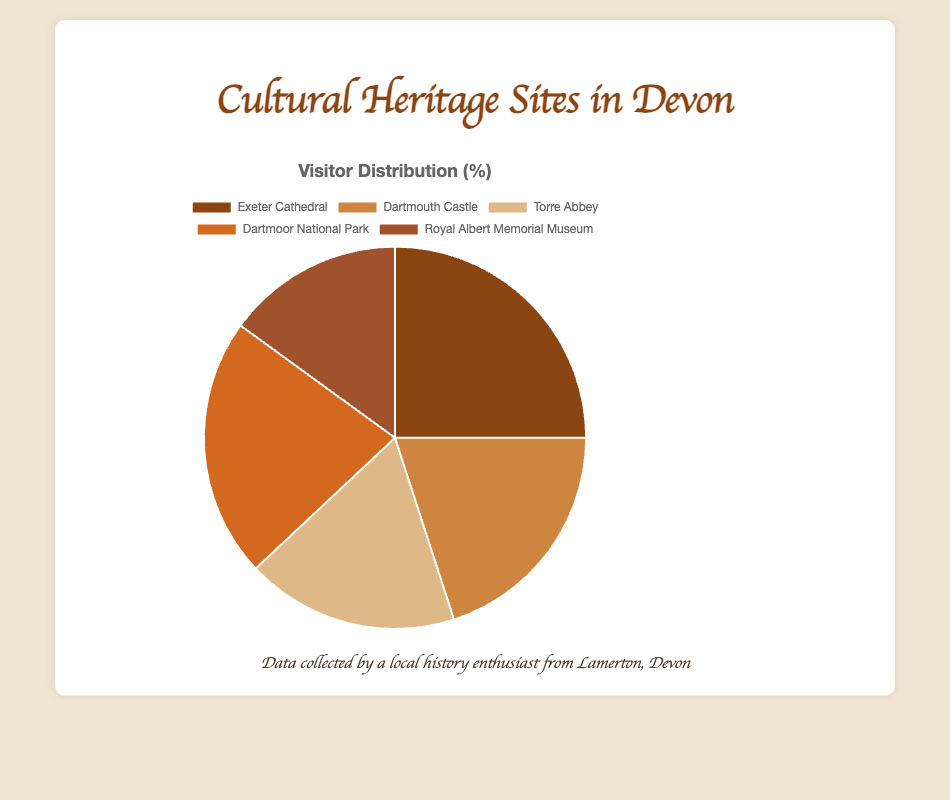Which cultural heritage site has the highest percentage of visitors? By looking at the pie chart, you can see the largest segment represents the site with the highest percentage of visitors. The largest segment is labeled "Exeter Cathedral".
Answer: Exeter Cathedral What is the combined percentage of visitors for Dartmouth Castle and Torre Abbey? Add the percentages of Dartmouth Castle (20%) and Torre Abbey (18%). This sum is 20% + 18% = 38%.
Answer: 38% Which site has fewer visitors, Royal Albert Memorial Museum or Dartmoor National Park? Compare the pie chart segments, the Royal Albert Memorial Museum segment is smaller than the Dartmoor National Park segment.
Answer: Royal Albert Memorial Museum How many percentage points more visitors does Exeter Cathedral have compared to Royal Albert Memorial Museum? Subtract the percentage of Royal Albert Memorial Museum (15%) from the percentage of Exeter Cathedral (25%). So, 25% - 15% = 10%.
Answer: 10 Which two sites together have the highest combined percentage of visitors? Find the two largest individual percentages and add them together. Exeter Cathedral (25%) and Dartmoor National Park (22%), their combined percentage is 25% + 22% = 47%.
Answer: Exeter Cathedral and Dartmoor National Park What is the difference in visitors between Torre Abbey and Dartmoor National Park? Subtract the percentage of Torre Abbey (18%) from Dartmoor National Park (22%). So, 22% - 18% = 4%.
Answer: 4 What percentage of visitors is represented by the smallest pie segment? The smallest pie segment is labeled "Royal Albert Memorial Museum" which has a percentage of 15%.
Answer: 15% Based on the pie chart, which colored segment represents Dartmoor National Park? Dartmoor National Park has a 22% visitor distribution and is represented by the color corresponding to that segment. It is visually identified in the pie chart.
Answer: 22% What's the average percentage of visitors across all five cultural heritage sites? Add up all the percentages and divide by the number of sites: (25% + 20% + 18% + 22% + 15%) / 5 = 100% / 5 = 20%.
Answer: 20 